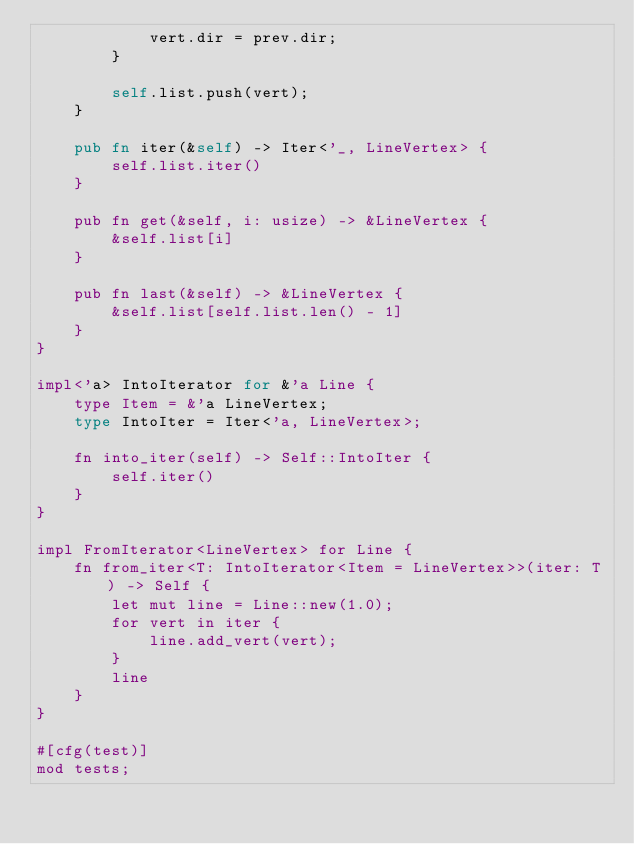<code> <loc_0><loc_0><loc_500><loc_500><_Rust_>            vert.dir = prev.dir;
        }

        self.list.push(vert);
    }

    pub fn iter(&self) -> Iter<'_, LineVertex> {
        self.list.iter()
    }

    pub fn get(&self, i: usize) -> &LineVertex {
        &self.list[i]
    }

    pub fn last(&self) -> &LineVertex {
        &self.list[self.list.len() - 1]
    }
}

impl<'a> IntoIterator for &'a Line {
    type Item = &'a LineVertex;
    type IntoIter = Iter<'a, LineVertex>;

    fn into_iter(self) -> Self::IntoIter {
        self.iter()
    }
}

impl FromIterator<LineVertex> for Line {
    fn from_iter<T: IntoIterator<Item = LineVertex>>(iter: T) -> Self {
        let mut line = Line::new(1.0);
        for vert in iter {
            line.add_vert(vert);
        }
        line
    }
}

#[cfg(test)]
mod tests;
</code> 